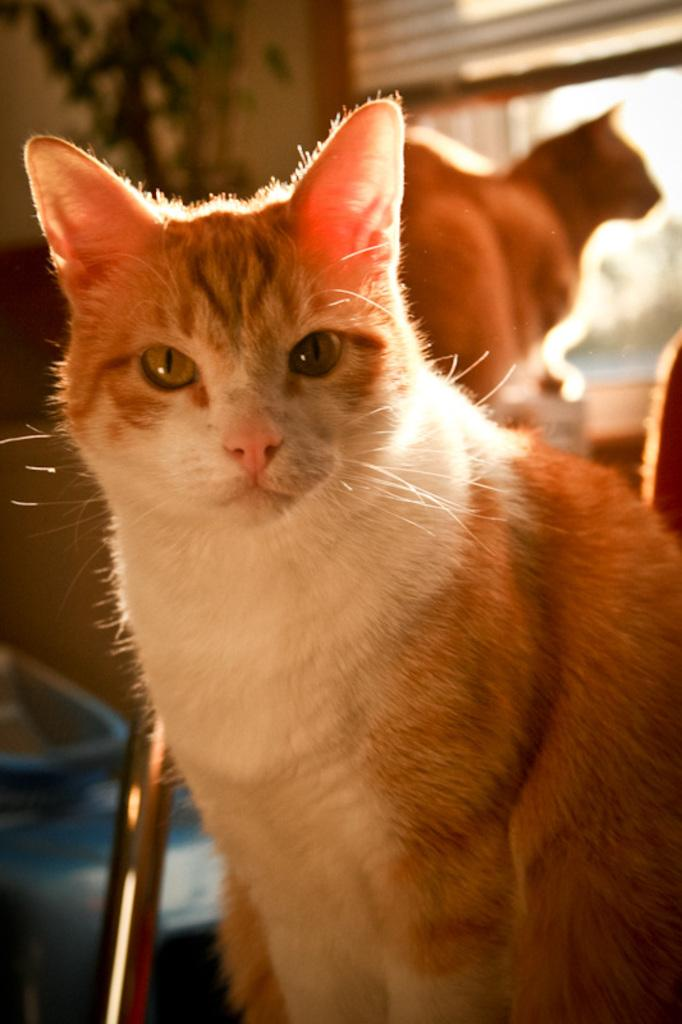What animals are in the center of the image? There are cats in the center of the image. What can be seen in the background of the image? There is a plant, a wall, and a window in the background of the image. What type of fuel is being used by the chickens in the image? There are no chickens present in the image, so it is not possible to determine what type of fuel they might be using. 